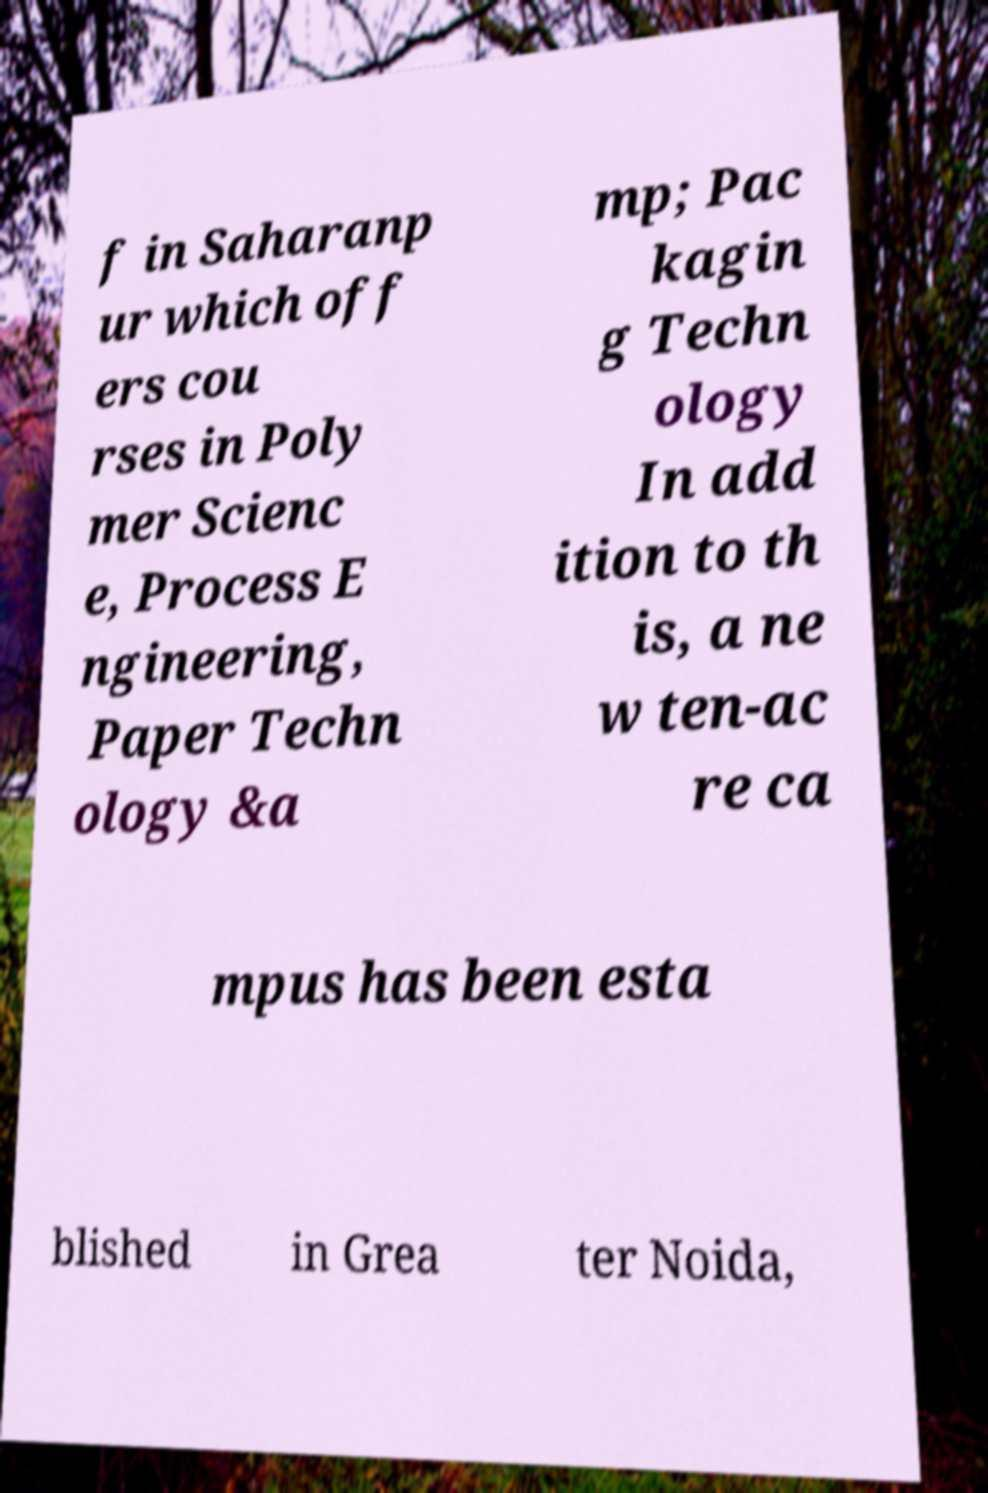Please read and relay the text visible in this image. What does it say? f in Saharanp ur which off ers cou rses in Poly mer Scienc e, Process E ngineering, Paper Techn ology &a mp; Pac kagin g Techn ology In add ition to th is, a ne w ten-ac re ca mpus has been esta blished in Grea ter Noida, 